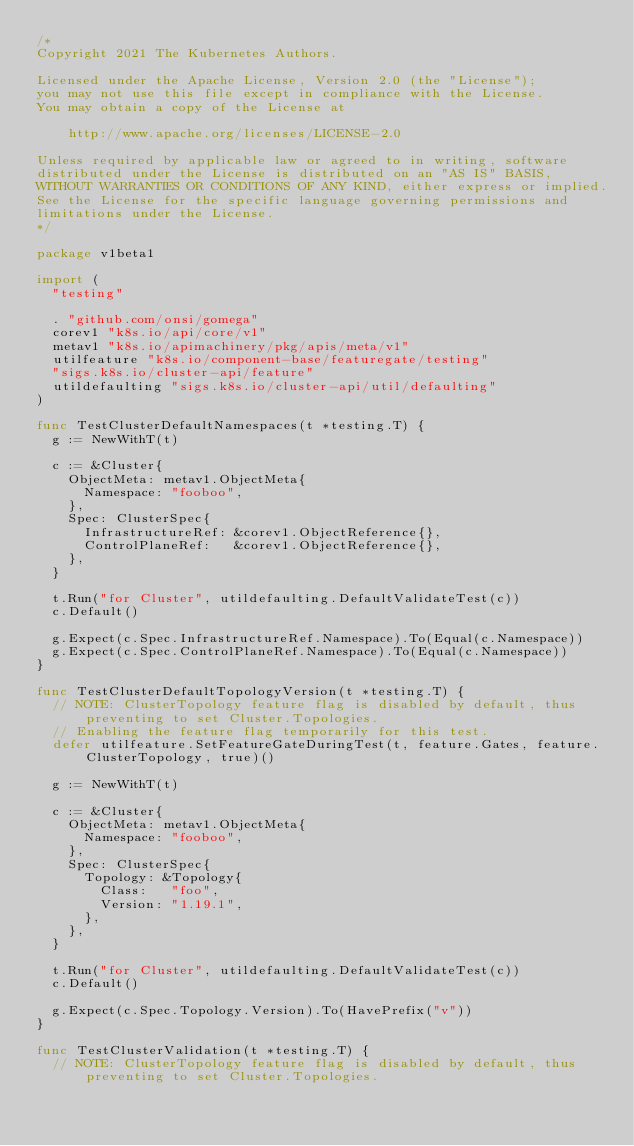Convert code to text. <code><loc_0><loc_0><loc_500><loc_500><_Go_>/*
Copyright 2021 The Kubernetes Authors.

Licensed under the Apache License, Version 2.0 (the "License");
you may not use this file except in compliance with the License.
You may obtain a copy of the License at

    http://www.apache.org/licenses/LICENSE-2.0

Unless required by applicable law or agreed to in writing, software
distributed under the License is distributed on an "AS IS" BASIS,
WITHOUT WARRANTIES OR CONDITIONS OF ANY KIND, either express or implied.
See the License for the specific language governing permissions and
limitations under the License.
*/

package v1beta1

import (
	"testing"

	. "github.com/onsi/gomega"
	corev1 "k8s.io/api/core/v1"
	metav1 "k8s.io/apimachinery/pkg/apis/meta/v1"
	utilfeature "k8s.io/component-base/featuregate/testing"
	"sigs.k8s.io/cluster-api/feature"
	utildefaulting "sigs.k8s.io/cluster-api/util/defaulting"
)

func TestClusterDefaultNamespaces(t *testing.T) {
	g := NewWithT(t)

	c := &Cluster{
		ObjectMeta: metav1.ObjectMeta{
			Namespace: "fooboo",
		},
		Spec: ClusterSpec{
			InfrastructureRef: &corev1.ObjectReference{},
			ControlPlaneRef:   &corev1.ObjectReference{},
		},
	}

	t.Run("for Cluster", utildefaulting.DefaultValidateTest(c))
	c.Default()

	g.Expect(c.Spec.InfrastructureRef.Namespace).To(Equal(c.Namespace))
	g.Expect(c.Spec.ControlPlaneRef.Namespace).To(Equal(c.Namespace))
}

func TestClusterDefaultTopologyVersion(t *testing.T) {
	// NOTE: ClusterTopology feature flag is disabled by default, thus preventing to set Cluster.Topologies.
	// Enabling the feature flag temporarily for this test.
	defer utilfeature.SetFeatureGateDuringTest(t, feature.Gates, feature.ClusterTopology, true)()

	g := NewWithT(t)

	c := &Cluster{
		ObjectMeta: metav1.ObjectMeta{
			Namespace: "fooboo",
		},
		Spec: ClusterSpec{
			Topology: &Topology{
				Class:   "foo",
				Version: "1.19.1",
			},
		},
	}

	t.Run("for Cluster", utildefaulting.DefaultValidateTest(c))
	c.Default()

	g.Expect(c.Spec.Topology.Version).To(HavePrefix("v"))
}

func TestClusterValidation(t *testing.T) {
	// NOTE: ClusterTopology feature flag is disabled by default, thus preventing to set Cluster.Topologies.
</code> 